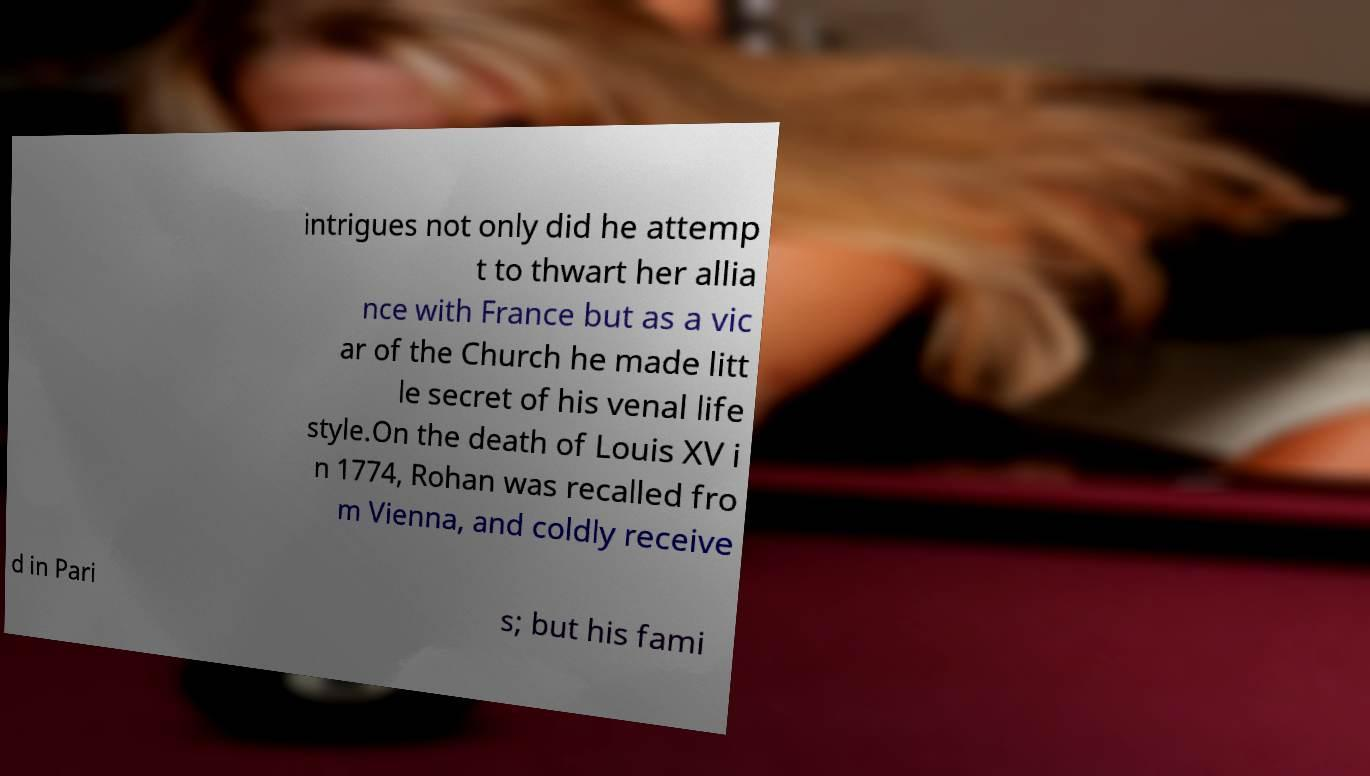I need the written content from this picture converted into text. Can you do that? intrigues not only did he attemp t to thwart her allia nce with France but as a vic ar of the Church he made litt le secret of his venal life style.On the death of Louis XV i n 1774, Rohan was recalled fro m Vienna, and coldly receive d in Pari s; but his fami 